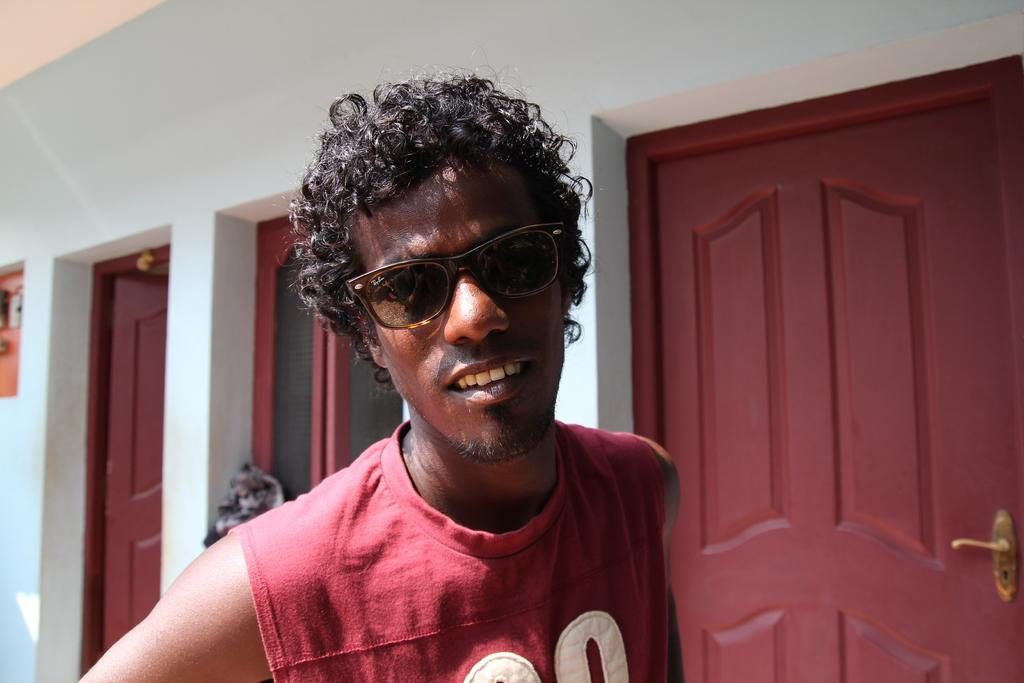What is the person in the image wearing on their face? The person in the image is wearing goggles. What can be seen in the background of the image? There are doors, a window, and walls in the background of the image. What grade does the person in the image receive for their performance? There is no indication of performance or grading in the image, as it only shows a person wearing goggles and a background with doors, a window, and walls. 